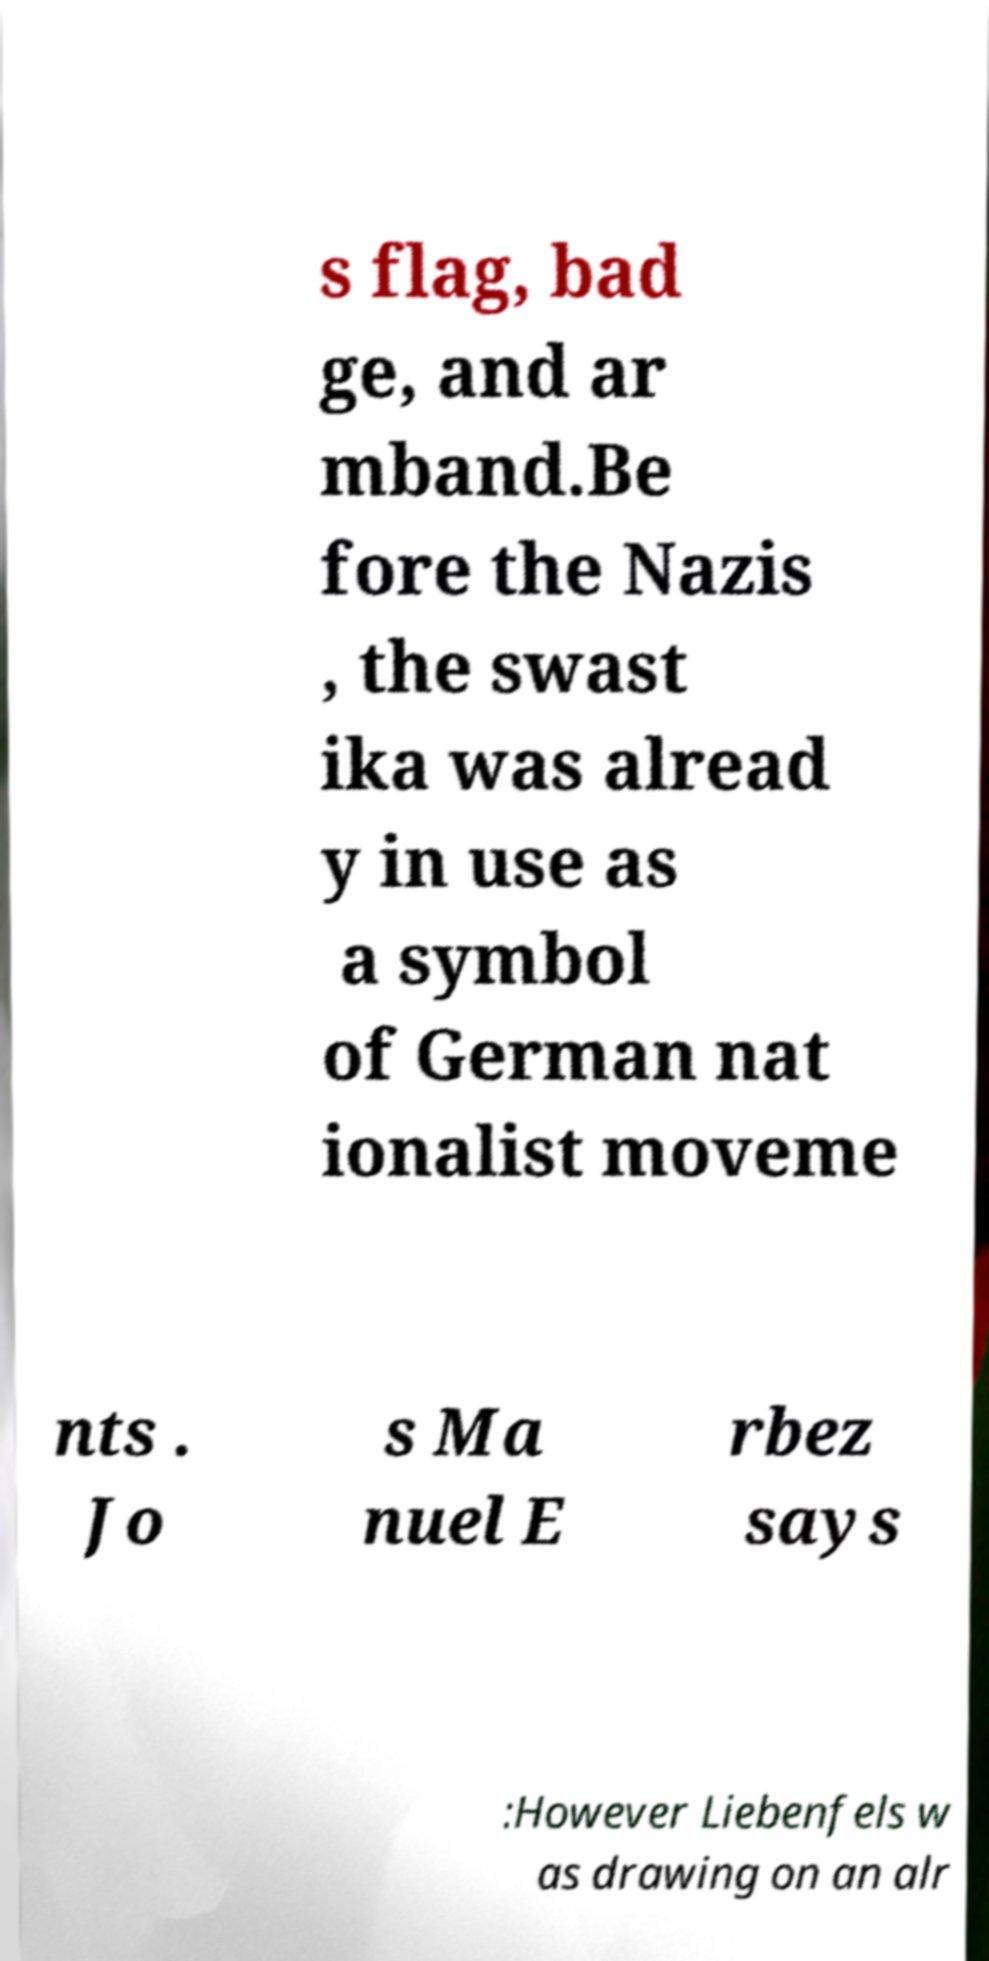Can you read and provide the text displayed in the image?This photo seems to have some interesting text. Can you extract and type it out for me? s flag, bad ge, and ar mband.Be fore the Nazis , the swast ika was alread y in use as a symbol of German nat ionalist moveme nts . Jo s Ma nuel E rbez says :However Liebenfels w as drawing on an alr 